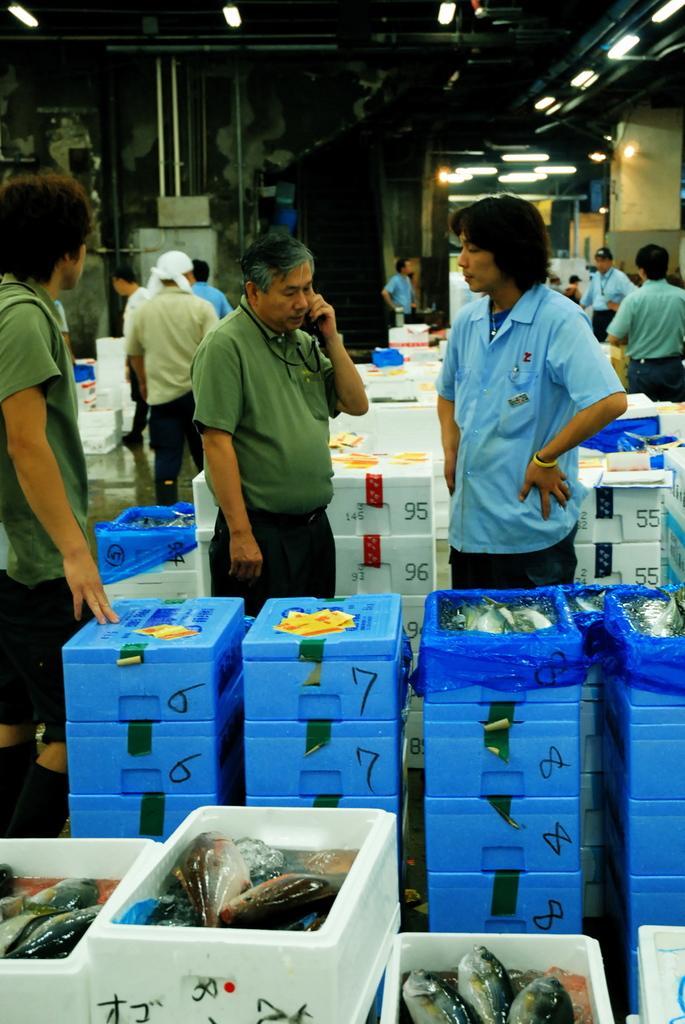Please provide a concise description of this image. In this picture we can see a group of people standing on the floor and boxes with fishes in it and in the background we can see rods, lights. 